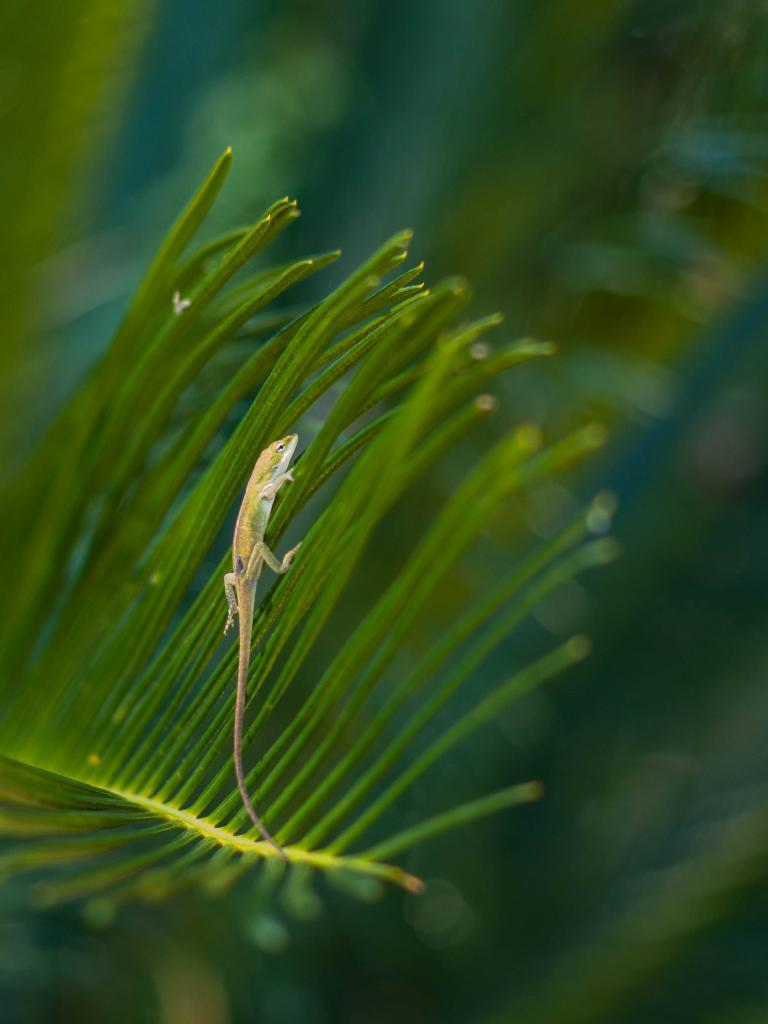What type of animal is in the image? There is a chameleon in the image. Where is the chameleon located? The chameleon is on a tree. What type of powder is being used by the chameleon in the image? There is no powder present in the image, and the chameleon is not using any powder. 